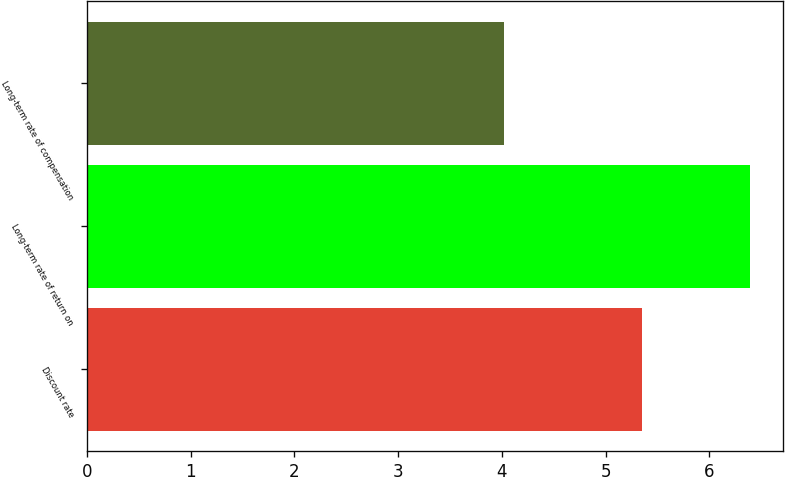Convert chart to OTSL. <chart><loc_0><loc_0><loc_500><loc_500><bar_chart><fcel>Discount rate<fcel>Long-term rate of return on<fcel>Long-term rate of compensation<nl><fcel>5.35<fcel>6.39<fcel>4.02<nl></chart> 